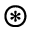Convert formula to latex. <formula><loc_0><loc_0><loc_500><loc_500>\circledast</formula> 